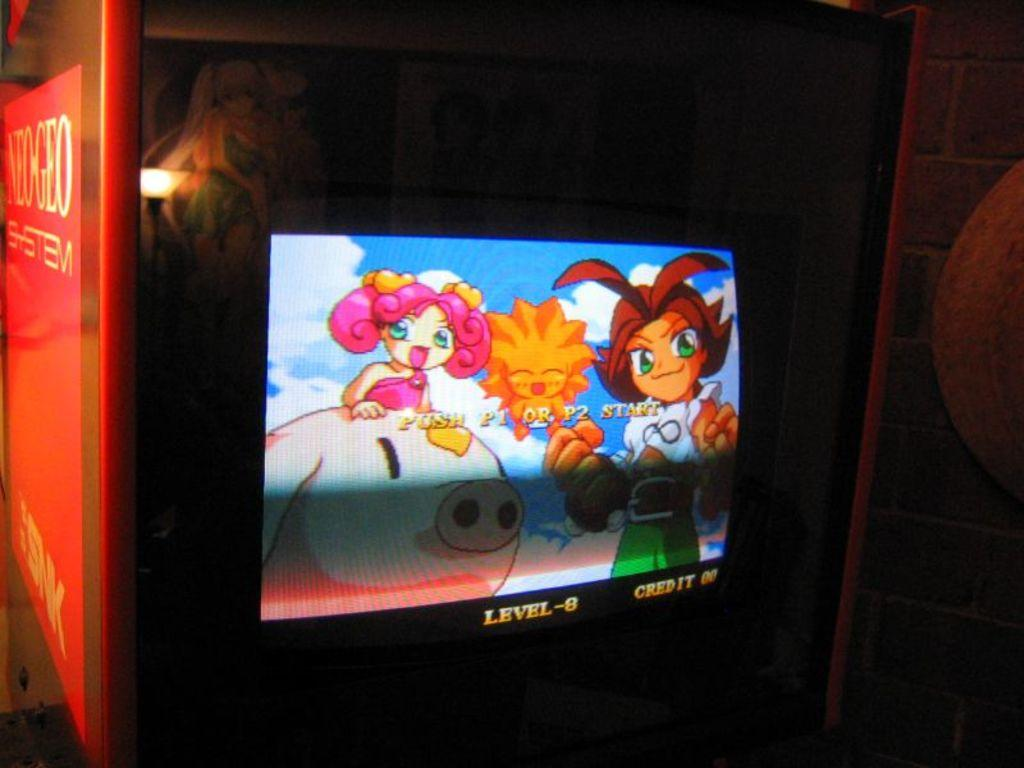<image>
Summarize the visual content of the image. A video game shows that the player is on level 8. 